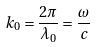<formula> <loc_0><loc_0><loc_500><loc_500>k _ { 0 } = \frac { 2 \pi } { \lambda _ { 0 } } = \frac { \omega } { c }</formula> 